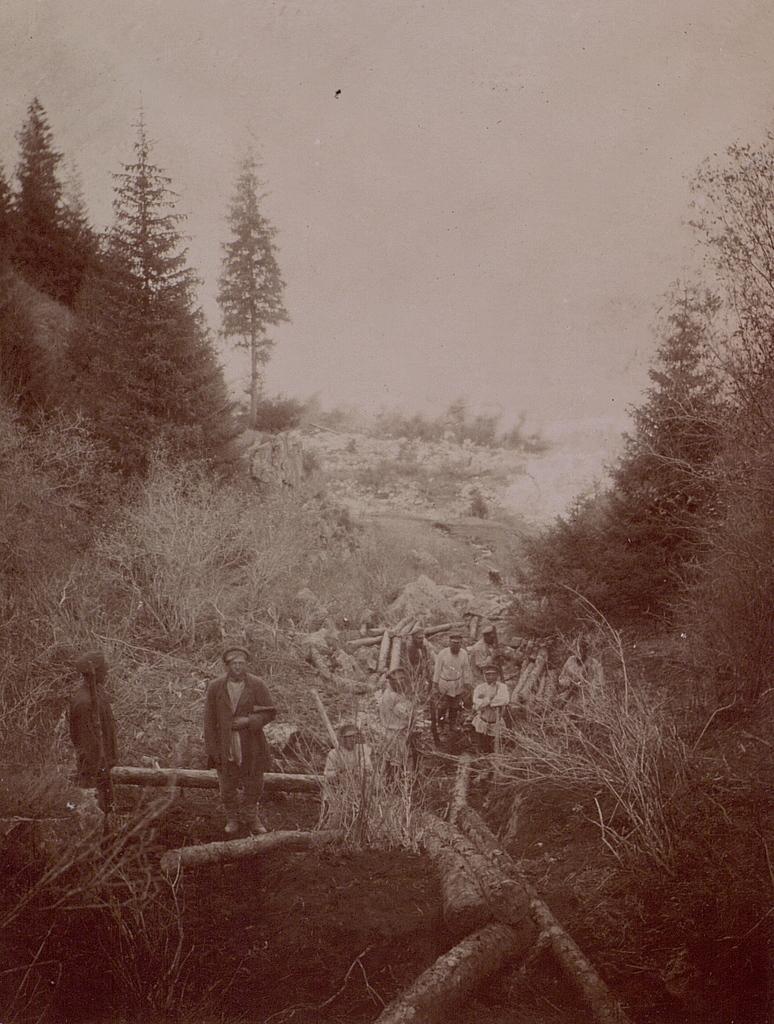In one or two sentences, can you explain what this image depicts? In this image there are people standing on the wooden logs. Behind them there are a few other people. At the bottom of the image there is grass on the surface. In the background of the image there are trees and sky. 